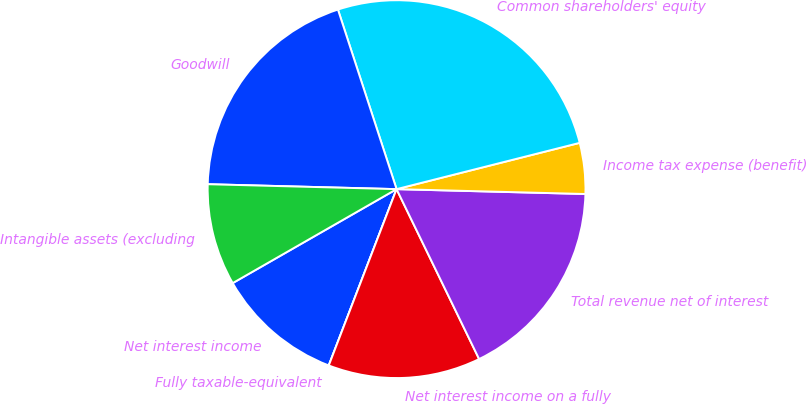Convert chart to OTSL. <chart><loc_0><loc_0><loc_500><loc_500><pie_chart><fcel>Net interest income<fcel>Fully taxable-equivalent<fcel>Net interest income on a fully<fcel>Total revenue net of interest<fcel>Income tax expense (benefit)<fcel>Common shareholders' equity<fcel>Goodwill<fcel>Intangible assets (excluding<nl><fcel>10.87%<fcel>0.0%<fcel>13.04%<fcel>17.39%<fcel>4.35%<fcel>26.08%<fcel>19.56%<fcel>8.7%<nl></chart> 